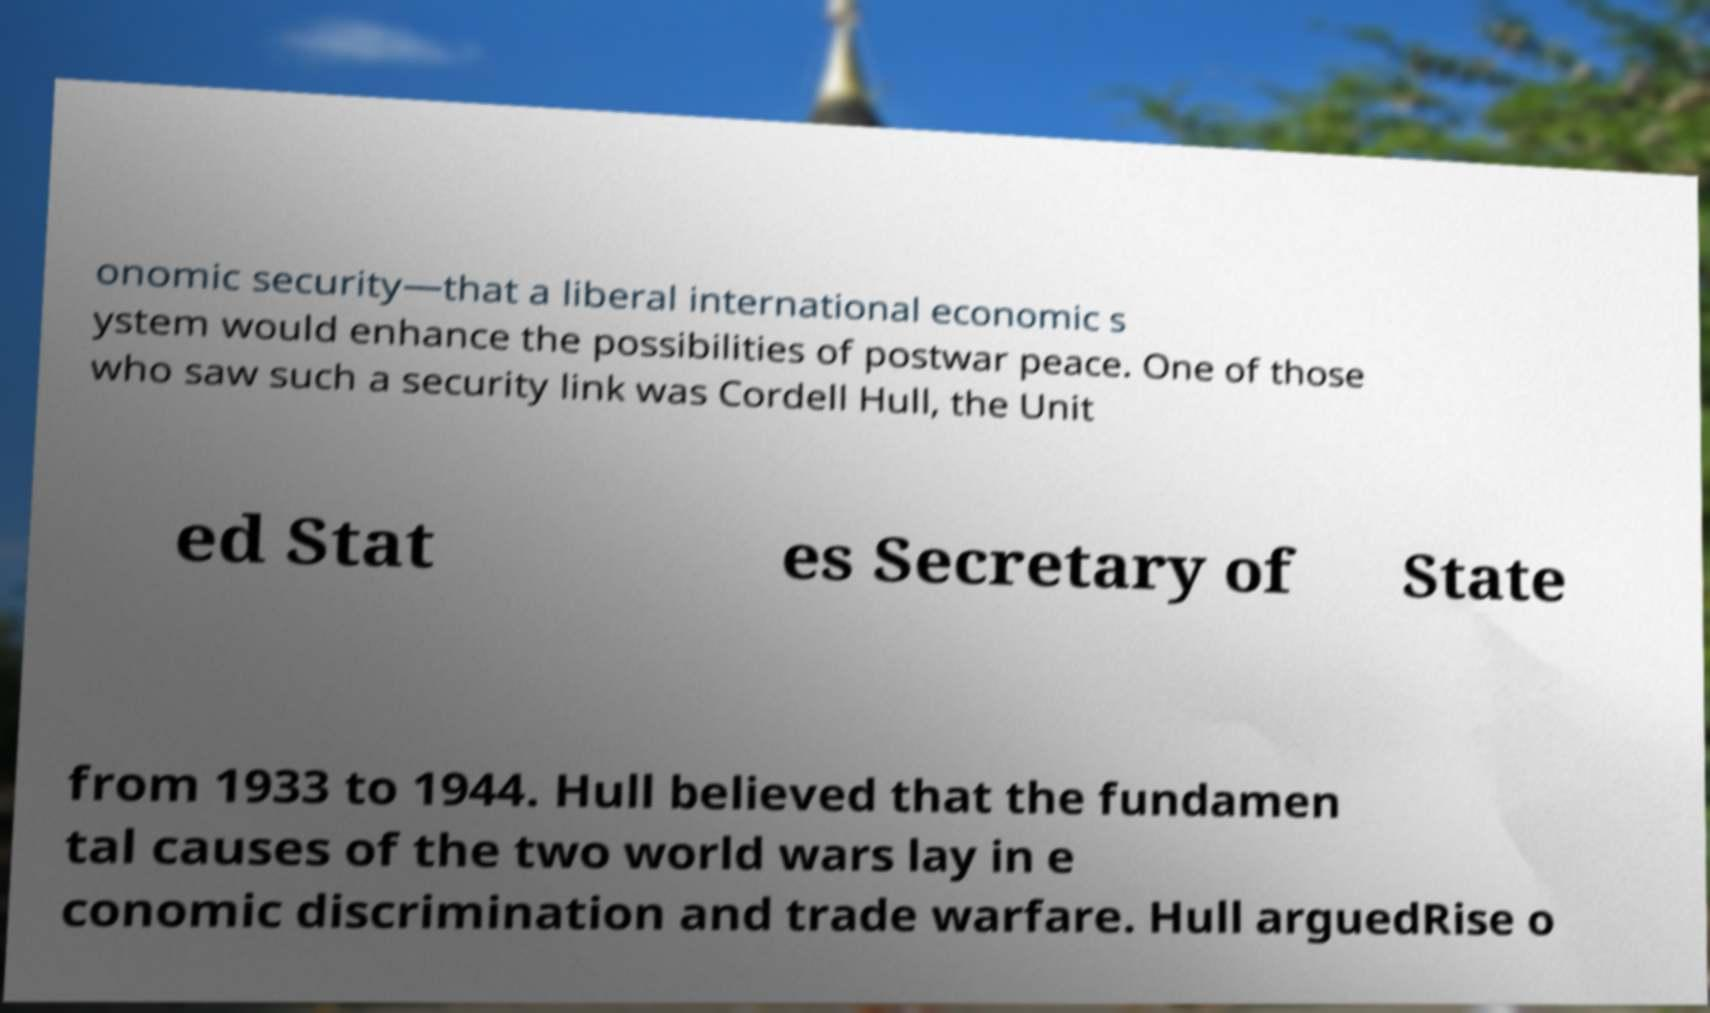There's text embedded in this image that I need extracted. Can you transcribe it verbatim? onomic security—that a liberal international economic s ystem would enhance the possibilities of postwar peace. One of those who saw such a security link was Cordell Hull, the Unit ed Stat es Secretary of State from 1933 to 1944. Hull believed that the fundamen tal causes of the two world wars lay in e conomic discrimination and trade warfare. Hull arguedRise o 